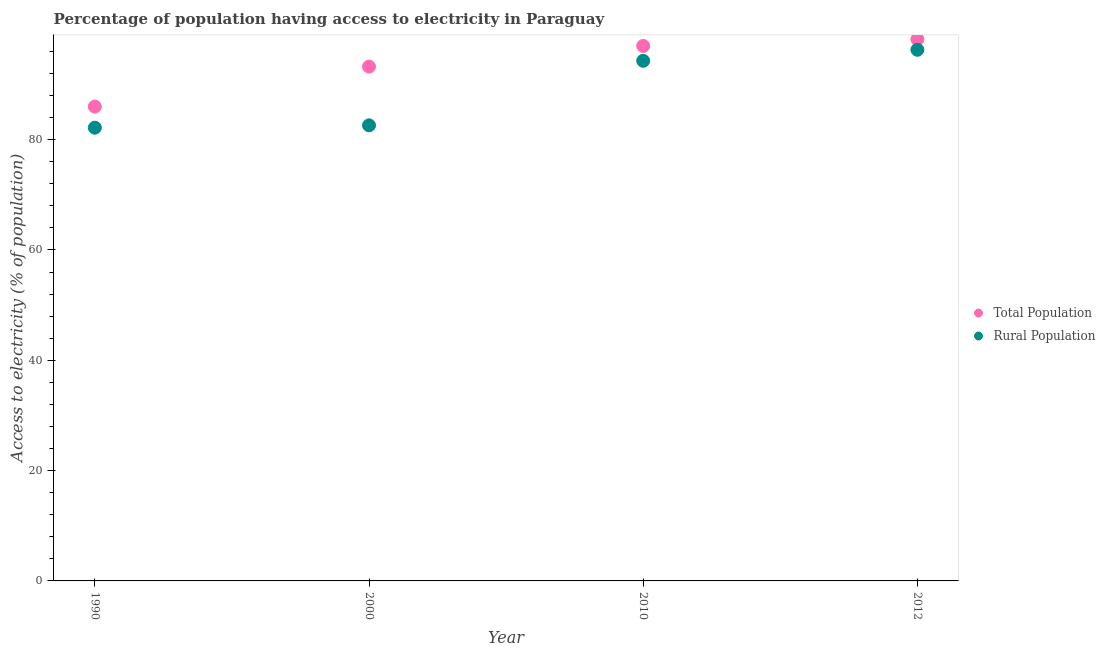Is the number of dotlines equal to the number of legend labels?
Keep it short and to the point. Yes. What is the percentage of population having access to electricity in 2010?
Offer a very short reply. 97. Across all years, what is the maximum percentage of rural population having access to electricity?
Offer a terse response. 96.3. Across all years, what is the minimum percentage of rural population having access to electricity?
Provide a short and direct response. 82.17. In which year was the percentage of rural population having access to electricity maximum?
Give a very brief answer. 2012. What is the total percentage of rural population having access to electricity in the graph?
Ensure brevity in your answer.  355.37. What is the difference between the percentage of rural population having access to electricity in 1990 and that in 2010?
Your answer should be very brief. -12.13. What is the difference between the percentage of population having access to electricity in 2012 and the percentage of rural population having access to electricity in 2000?
Offer a terse response. 15.6. What is the average percentage of rural population having access to electricity per year?
Offer a terse response. 88.84. In the year 2010, what is the difference between the percentage of rural population having access to electricity and percentage of population having access to electricity?
Keep it short and to the point. -2.7. In how many years, is the percentage of rural population having access to electricity greater than 52 %?
Offer a terse response. 4. What is the ratio of the percentage of population having access to electricity in 2010 to that in 2012?
Your answer should be compact. 0.99. Is the percentage of population having access to electricity in 2010 less than that in 2012?
Your answer should be very brief. Yes. What is the difference between the highest and the second highest percentage of rural population having access to electricity?
Your answer should be very brief. 2. What is the difference between the highest and the lowest percentage of rural population having access to electricity?
Your answer should be compact. 14.13. Does the percentage of population having access to electricity monotonically increase over the years?
Offer a terse response. Yes. Is the percentage of rural population having access to electricity strictly greater than the percentage of population having access to electricity over the years?
Your answer should be very brief. No. Is the percentage of population having access to electricity strictly less than the percentage of rural population having access to electricity over the years?
Make the answer very short. No. Does the graph contain any zero values?
Your answer should be very brief. No. How many legend labels are there?
Keep it short and to the point. 2. How are the legend labels stacked?
Your response must be concise. Vertical. What is the title of the graph?
Provide a succinct answer. Percentage of population having access to electricity in Paraguay. What is the label or title of the X-axis?
Give a very brief answer. Year. What is the label or title of the Y-axis?
Your response must be concise. Access to electricity (% of population). What is the Access to electricity (% of population) of Total Population in 1990?
Your answer should be compact. 86. What is the Access to electricity (% of population) in Rural Population in 1990?
Your response must be concise. 82.17. What is the Access to electricity (% of population) in Total Population in 2000?
Offer a terse response. 93.25. What is the Access to electricity (% of population) in Rural Population in 2000?
Provide a succinct answer. 82.6. What is the Access to electricity (% of population) of Total Population in 2010?
Your answer should be very brief. 97. What is the Access to electricity (% of population) of Rural Population in 2010?
Give a very brief answer. 94.3. What is the Access to electricity (% of population) in Total Population in 2012?
Give a very brief answer. 98.2. What is the Access to electricity (% of population) in Rural Population in 2012?
Provide a succinct answer. 96.3. Across all years, what is the maximum Access to electricity (% of population) in Total Population?
Offer a terse response. 98.2. Across all years, what is the maximum Access to electricity (% of population) of Rural Population?
Provide a succinct answer. 96.3. Across all years, what is the minimum Access to electricity (% of population) of Total Population?
Provide a succinct answer. 86. Across all years, what is the minimum Access to electricity (% of population) in Rural Population?
Provide a succinct answer. 82.17. What is the total Access to electricity (% of population) in Total Population in the graph?
Offer a very short reply. 374.45. What is the total Access to electricity (% of population) of Rural Population in the graph?
Make the answer very short. 355.37. What is the difference between the Access to electricity (% of population) in Total Population in 1990 and that in 2000?
Provide a succinct answer. -7.25. What is the difference between the Access to electricity (% of population) in Rural Population in 1990 and that in 2000?
Keep it short and to the point. -0.43. What is the difference between the Access to electricity (% of population) in Rural Population in 1990 and that in 2010?
Make the answer very short. -12.13. What is the difference between the Access to electricity (% of population) in Rural Population in 1990 and that in 2012?
Provide a short and direct response. -14.13. What is the difference between the Access to electricity (% of population) of Total Population in 2000 and that in 2010?
Offer a terse response. -3.75. What is the difference between the Access to electricity (% of population) in Total Population in 2000 and that in 2012?
Keep it short and to the point. -4.95. What is the difference between the Access to electricity (% of population) of Rural Population in 2000 and that in 2012?
Your answer should be compact. -13.7. What is the difference between the Access to electricity (% of population) in Total Population in 1990 and the Access to electricity (% of population) in Rural Population in 2000?
Provide a short and direct response. 3.4. What is the difference between the Access to electricity (% of population) of Total Population in 2000 and the Access to electricity (% of population) of Rural Population in 2010?
Keep it short and to the point. -1.05. What is the difference between the Access to electricity (% of population) in Total Population in 2000 and the Access to electricity (% of population) in Rural Population in 2012?
Ensure brevity in your answer.  -3.05. What is the difference between the Access to electricity (% of population) in Total Population in 2010 and the Access to electricity (% of population) in Rural Population in 2012?
Provide a short and direct response. 0.7. What is the average Access to electricity (% of population) in Total Population per year?
Offer a terse response. 93.61. What is the average Access to electricity (% of population) in Rural Population per year?
Provide a succinct answer. 88.84. In the year 1990, what is the difference between the Access to electricity (% of population) in Total Population and Access to electricity (% of population) in Rural Population?
Offer a terse response. 3.83. In the year 2000, what is the difference between the Access to electricity (% of population) in Total Population and Access to electricity (% of population) in Rural Population?
Offer a very short reply. 10.65. In the year 2012, what is the difference between the Access to electricity (% of population) in Total Population and Access to electricity (% of population) in Rural Population?
Keep it short and to the point. 1.9. What is the ratio of the Access to electricity (% of population) of Total Population in 1990 to that in 2000?
Ensure brevity in your answer.  0.92. What is the ratio of the Access to electricity (% of population) in Total Population in 1990 to that in 2010?
Provide a short and direct response. 0.89. What is the ratio of the Access to electricity (% of population) in Rural Population in 1990 to that in 2010?
Offer a terse response. 0.87. What is the ratio of the Access to electricity (% of population) of Total Population in 1990 to that in 2012?
Keep it short and to the point. 0.88. What is the ratio of the Access to electricity (% of population) of Rural Population in 1990 to that in 2012?
Offer a very short reply. 0.85. What is the ratio of the Access to electricity (% of population) in Total Population in 2000 to that in 2010?
Provide a succinct answer. 0.96. What is the ratio of the Access to electricity (% of population) in Rural Population in 2000 to that in 2010?
Make the answer very short. 0.88. What is the ratio of the Access to electricity (% of population) in Total Population in 2000 to that in 2012?
Your answer should be compact. 0.95. What is the ratio of the Access to electricity (% of population) of Rural Population in 2000 to that in 2012?
Ensure brevity in your answer.  0.86. What is the ratio of the Access to electricity (% of population) in Total Population in 2010 to that in 2012?
Offer a terse response. 0.99. What is the ratio of the Access to electricity (% of population) in Rural Population in 2010 to that in 2012?
Offer a terse response. 0.98. What is the difference between the highest and the second highest Access to electricity (% of population) in Rural Population?
Offer a very short reply. 2. What is the difference between the highest and the lowest Access to electricity (% of population) of Rural Population?
Give a very brief answer. 14.13. 